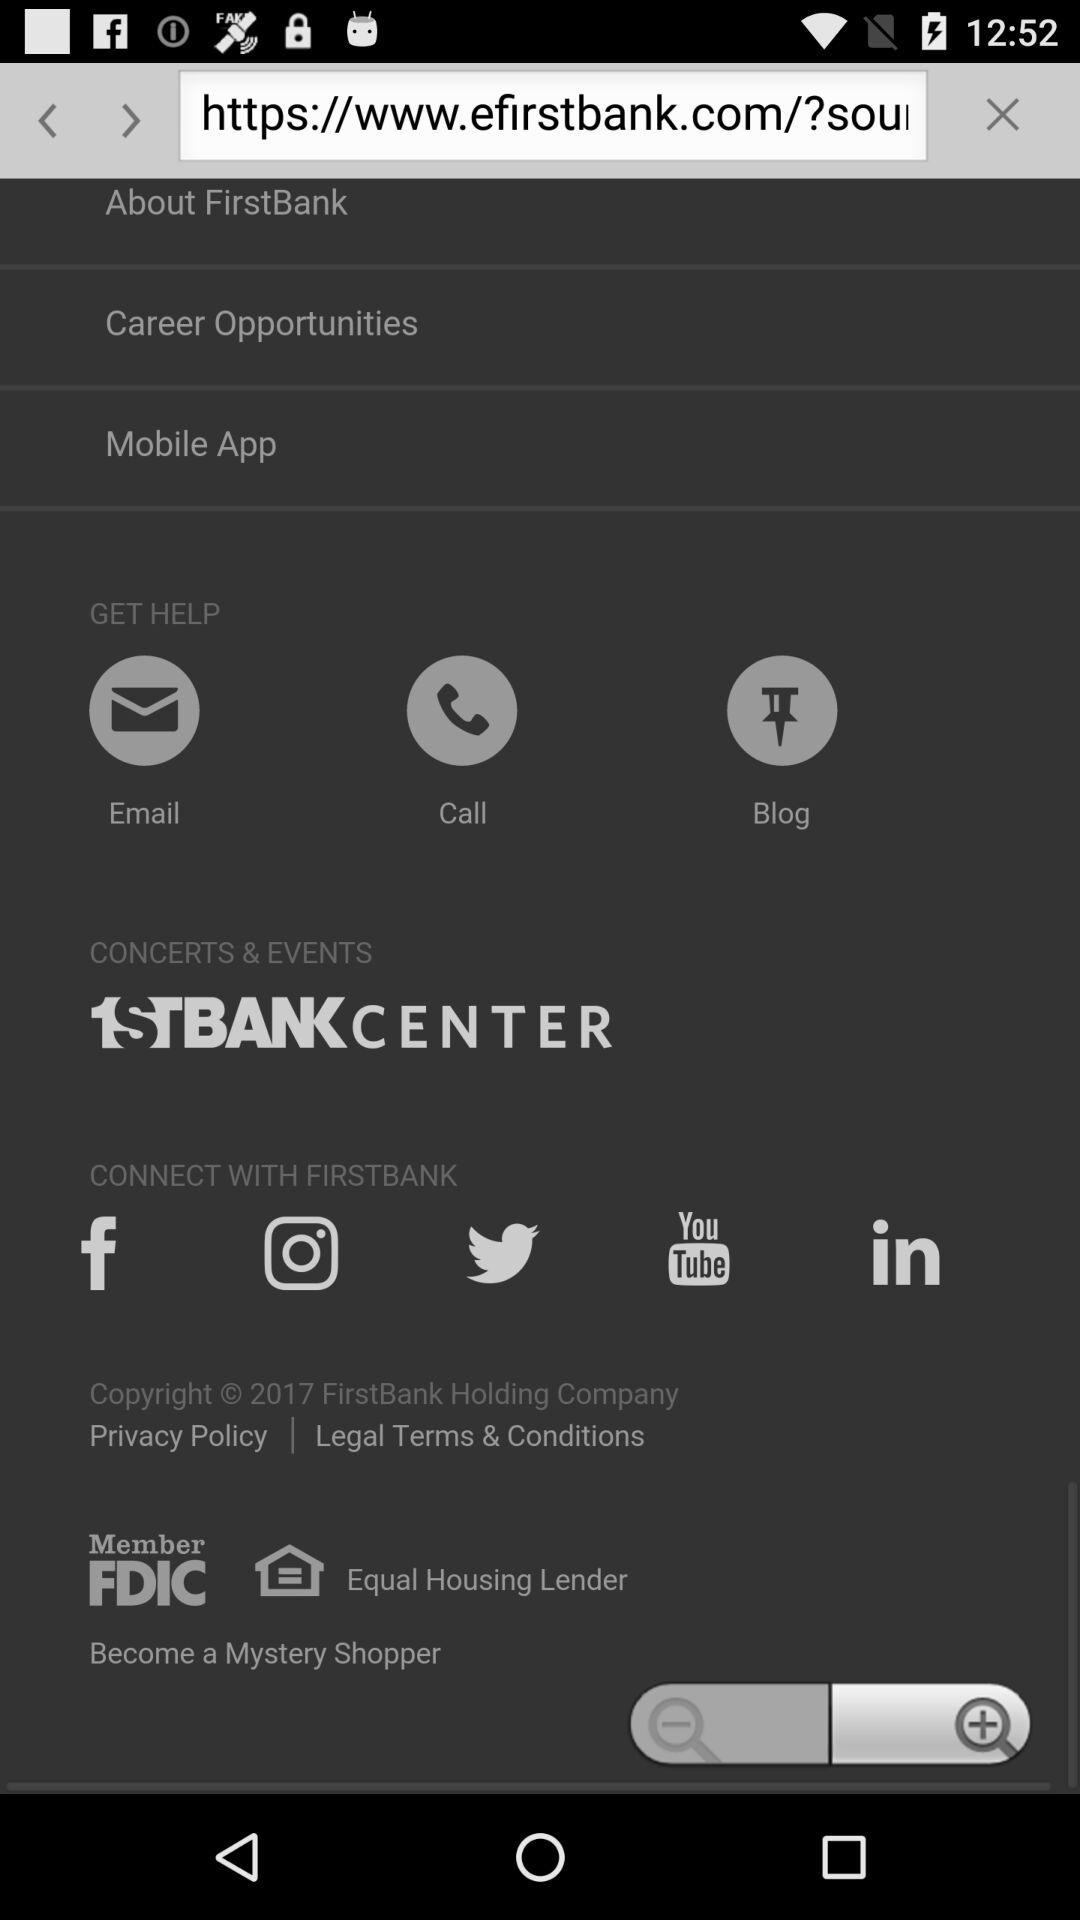What are the different social networking options for connecting? The different social networking options for connecting are "Facebook", "Instagram", "Twitter", "YouTube" and "LinkedIn". 